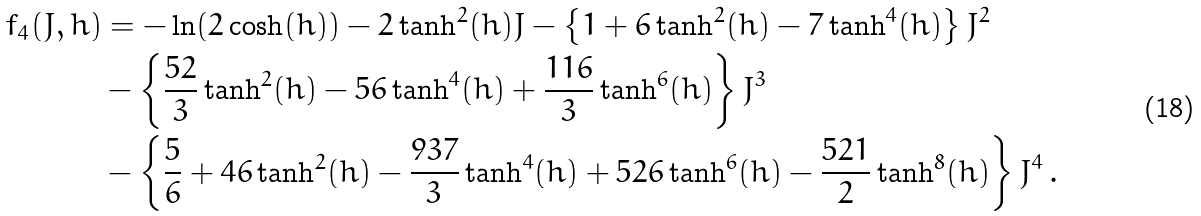<formula> <loc_0><loc_0><loc_500><loc_500>f _ { 4 } ( J , h ) & = - \ln ( 2 \cosh ( h ) ) - 2 \tanh ^ { 2 } ( h ) J - \left \{ 1 + 6 \tanh ^ { 2 } ( h ) - 7 \tanh ^ { 4 } ( h ) \right \} J ^ { 2 } \\ & - \left \{ \frac { 5 2 } { 3 } \tanh ^ { 2 } ( h ) - 5 6 \tanh ^ { 4 } ( h ) + \frac { 1 1 6 } { 3 } \tanh ^ { 6 } ( h ) \right \} J ^ { 3 } \\ & - \left \{ \frac { 5 } { 6 } + 4 6 \tanh ^ { 2 } ( h ) - \frac { 9 3 7 } { 3 } \tanh ^ { 4 } ( h ) + 5 2 6 \tanh ^ { 6 } ( h ) - \frac { 5 2 1 } { 2 } \tanh ^ { 8 } ( h ) \right \} J ^ { 4 } \, .</formula> 